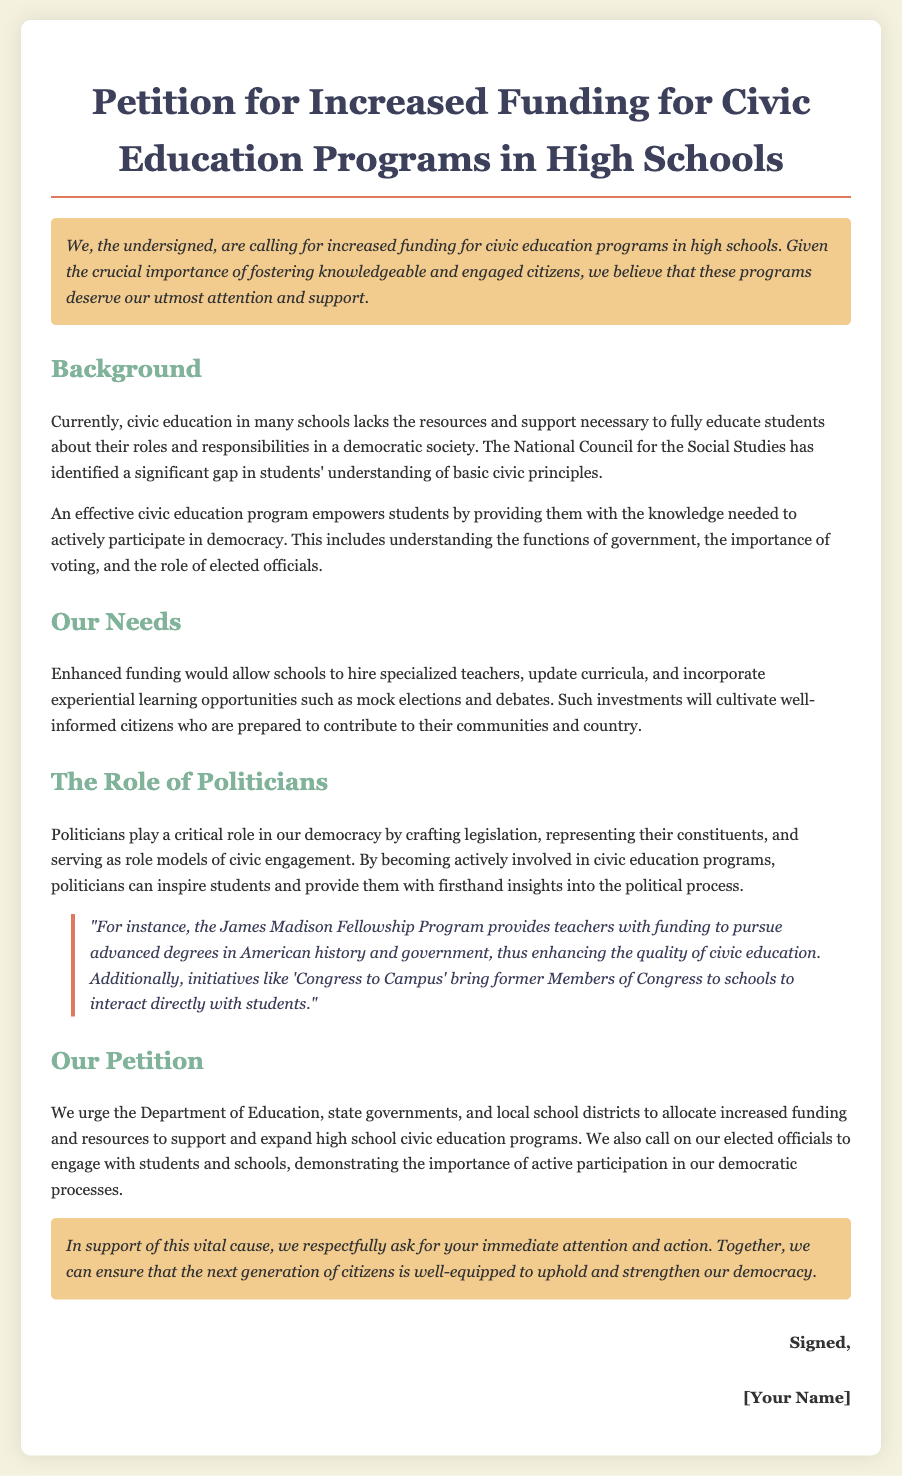What is the title of the petition? The title can be found at the top of the document, which summarizes the main request being made.
Answer: Petition for Increased Funding for Civic Education Programs in High Schools What organization's insights are mentioned regarding civic education gaps? The document refers to an organization that has identified issues in civic education programs.
Answer: National Council for the Social Studies What is one benefit of enhanced funding for civic education? The text mentions a specific improvement that funding could enable.
Answer: Hire specialized teachers What program is mentioned that provides funding for teachers? The document cites a fellowship designed to support teachers' educational advancement.
Answer: James Madison Fellowship Program What type of learning opportunities are suggested to be included in civic education? The text directly mentions the type of activities that would enhance students' understanding of democracy.
Answer: Experiential learning opportunities According to the petition, what should elected officials do to promote civic education? The document emphasizes the involvement of politicians in schools as a crucial activity.
Answer: Engage with students Who is called upon to allocate increased funding for civic education? The petition clearly identifies the entities it is directed at regarding funding.
Answer: Department of Education, state governments, and local school districts What is highlighted as a goal of the petition? The main aim of the petition focuses on a specific outcome for the next generation.
Answer: Well-equipped to uphold and strengthen our democracy What is the quoted initiative that brings former Members of Congress to schools? The document presents a specific initiative aimed at enhancing civic engagement among students.
Answer: Congress to Campus 